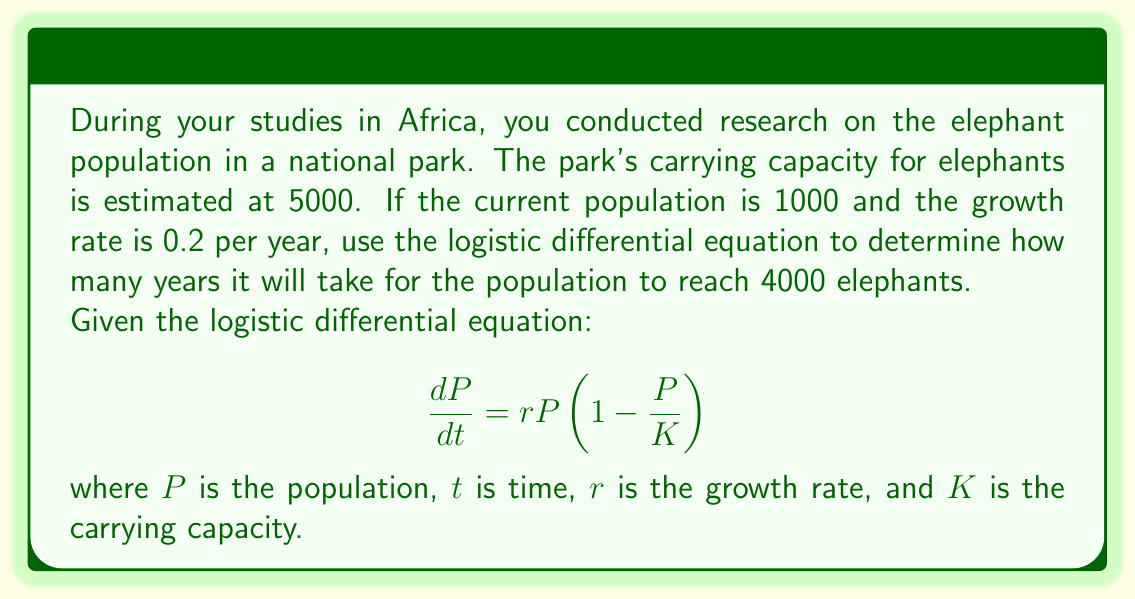Show me your answer to this math problem. To solve this problem, we'll use the logistic growth model and its solution:

1) The logistic differential equation is:

   $$\frac{dP}{dt} = rP(1-\frac{P}{K})$$

2) The solution to this equation is:

   $$P(t) = \frac{K}{1 + (\frac{K}{P_0} - 1)e^{-rt}}$$

   where $P_0$ is the initial population.

3) We're given:
   - $K = 5000$ (carrying capacity)
   - $P_0 = 1000$ (initial population)
   - $r = 0.2$ (growth rate)
   - We want to find $t$ when $P(t) = 4000$

4) Substituting these values into the equation:

   $$4000 = \frac{5000}{1 + (\frac{5000}{1000} - 1)e^{-0.2t}}$$

5) Simplify:

   $$4000 = \frac{5000}{1 + 4e^{-0.2t}}$$

6) Multiply both sides by $(1 + 4e^{-0.2t})$:

   $$4000(1 + 4e^{-0.2t}) = 5000$$

7) Expand:

   $$4000 + 16000e^{-0.2t} = 5000$$

8) Subtract 4000 from both sides:

   $$16000e^{-0.2t} = 1000$$

9) Divide both sides by 16000:

   $$e^{-0.2t} = \frac{1}{16}$$

10) Take the natural log of both sides:

    $$-0.2t = \ln(\frac{1}{16}) = -\ln(16)$$

11) Divide both sides by -0.2:

    $$t = \frac{\ln(16)}{0.2} \approx 13.86$$

Therefore, it will take approximately 13.86 years for the elephant population to reach 4000.
Answer: Approximately 13.86 years 